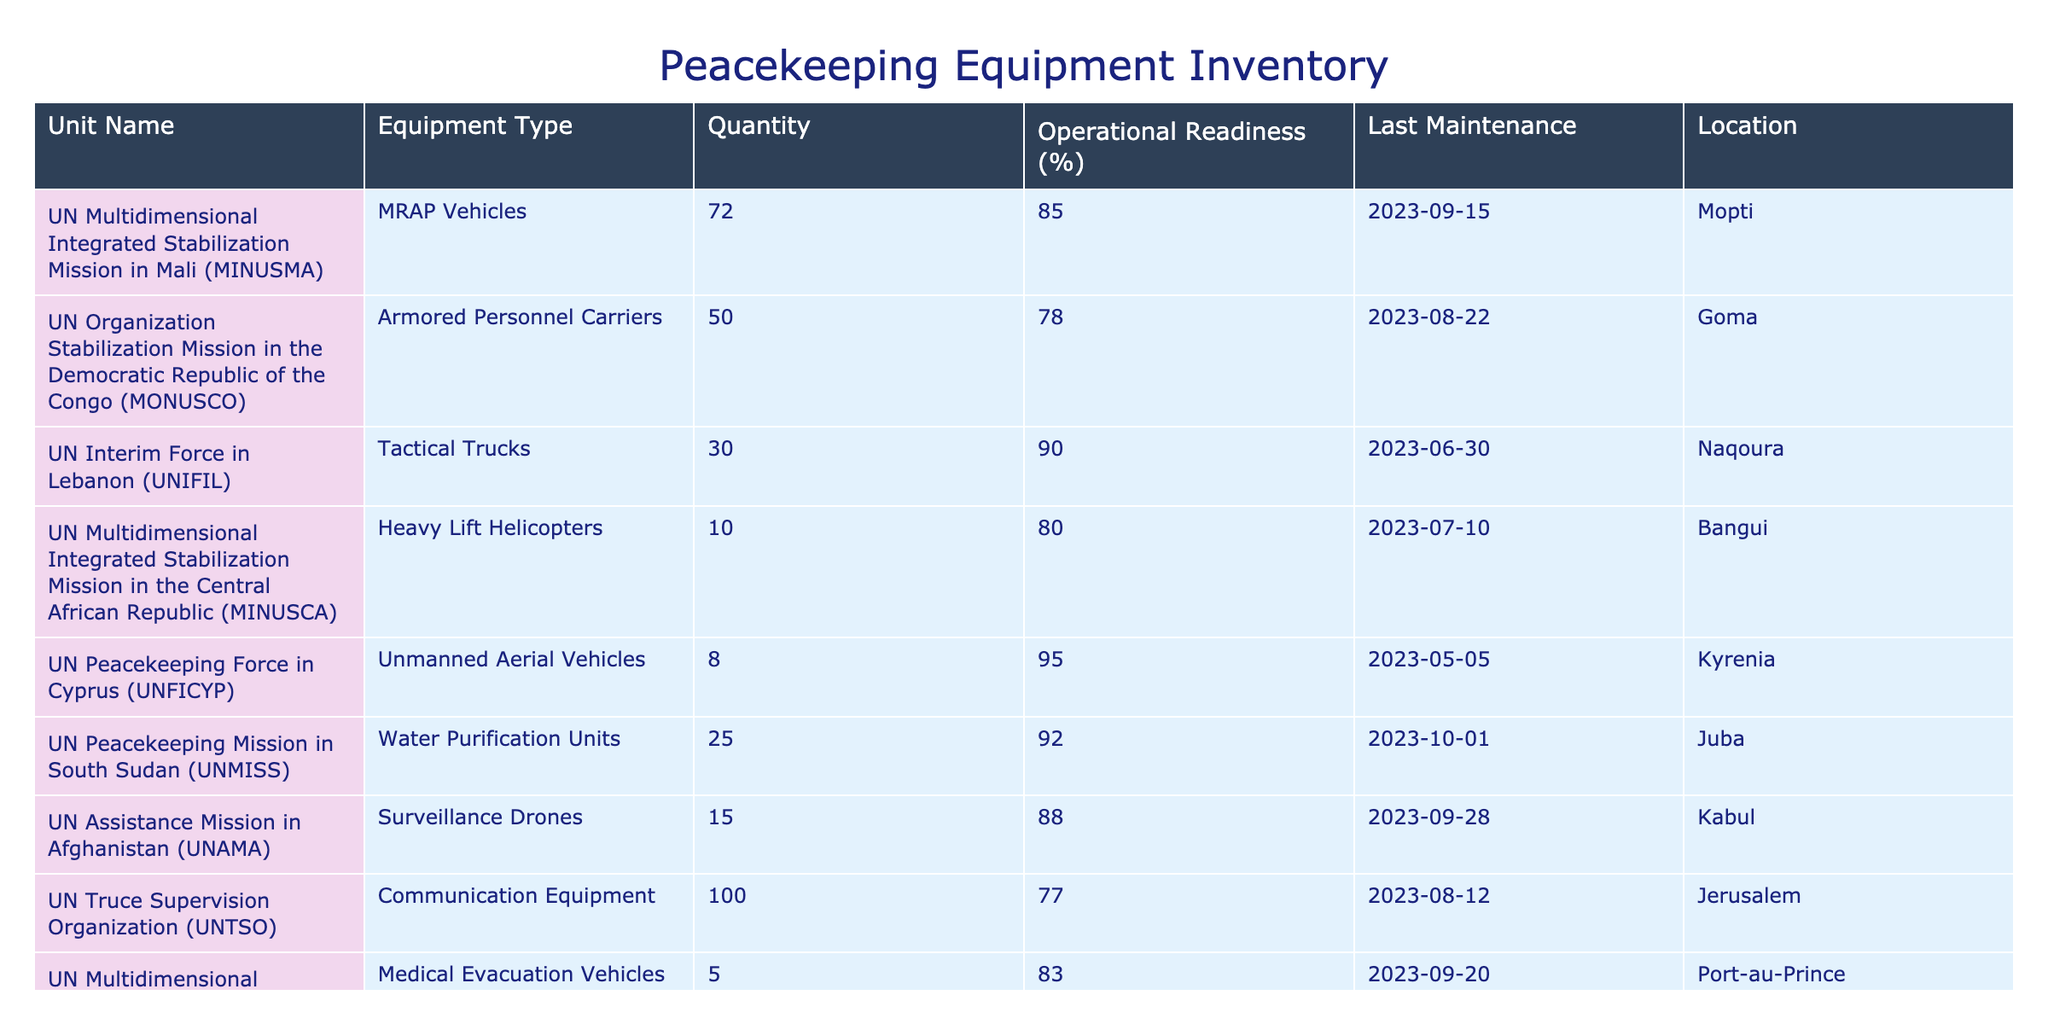What is the total quantity of MRAP Vehicles available? The table shows that the UN Multidimensional Integrated Stabilization Mission in Mali has 72 MRAP Vehicles listed under Quantity. Therefore, the total quantity is simply 72 as there are no other units mentioned for MRAP Vehicles.
Answer: 72 Which unit has the highest operational readiness percentage? By comparing the Operational Readiness percentages across all units, the UN Peacekeeping Force in Cyprus has the highest percentage at 95%.
Answer: 95% What is the average operational readiness percentage of the peacekeeping units listed? To find the average, sum all operational readiness percentages: (85 + 78 + 90 + 80 + 95 + 92 + 88 + 77 + 83 + 75) = 838. There are 10 units, so the average is 838 / 10 = 83.8.
Answer: 83.8 Does the UN Multidimensional Integrated Stabilization Mission in the Central African Republic have more than 10 Heavy Lift Helicopters? The table indicates that there are 10 Heavy Lift Helicopters for MINUSCA, which means it does not have more than 10. Therefore, the answer is no.
Answer: No Which peacekeeping unit has the least quantity of equipment listed? From the table, the UN Stabilization Mission in the Republic of Mali (MINSUMA) has the least quantity of equipment, with only 3 Field Hospital Units listed.
Answer: 3 What is the difference in operational readiness between the unit with the highest and the lowest percentage? The highest operational readiness is 95% (UN Peacekeeping Force in Cyprus) and the lowest is 75% (UN Stabilization Mission in the Republic of Mali). The difference is 95% - 75% = 20%.
Answer: 20% Are there any units with more than 50 communication equipment items? The table shows a quantity of 100 for Communication Equipment under UN Truce Supervision Organization, which means there is at least one unit with more than 50 items. Therefore, the answer is yes.
Answer: Yes What is the sum of all Water Purification Units and Tactical Trucks across the peacekeeping operations? Water Purification Units from UNMISS have 25 and Tactical Trucks from UNIFIL have 30. Adding these gives 25 + 30 = 55.
Answer: 55 Which location has the most operational readiness listed in the table? The operational readiness percentage for each unit's location varies, but the highest value is from Kyrenia with 95%. Therefore, we say that the location with the most operational readiness listed is Kyrenia.
Answer: Kyrenia 